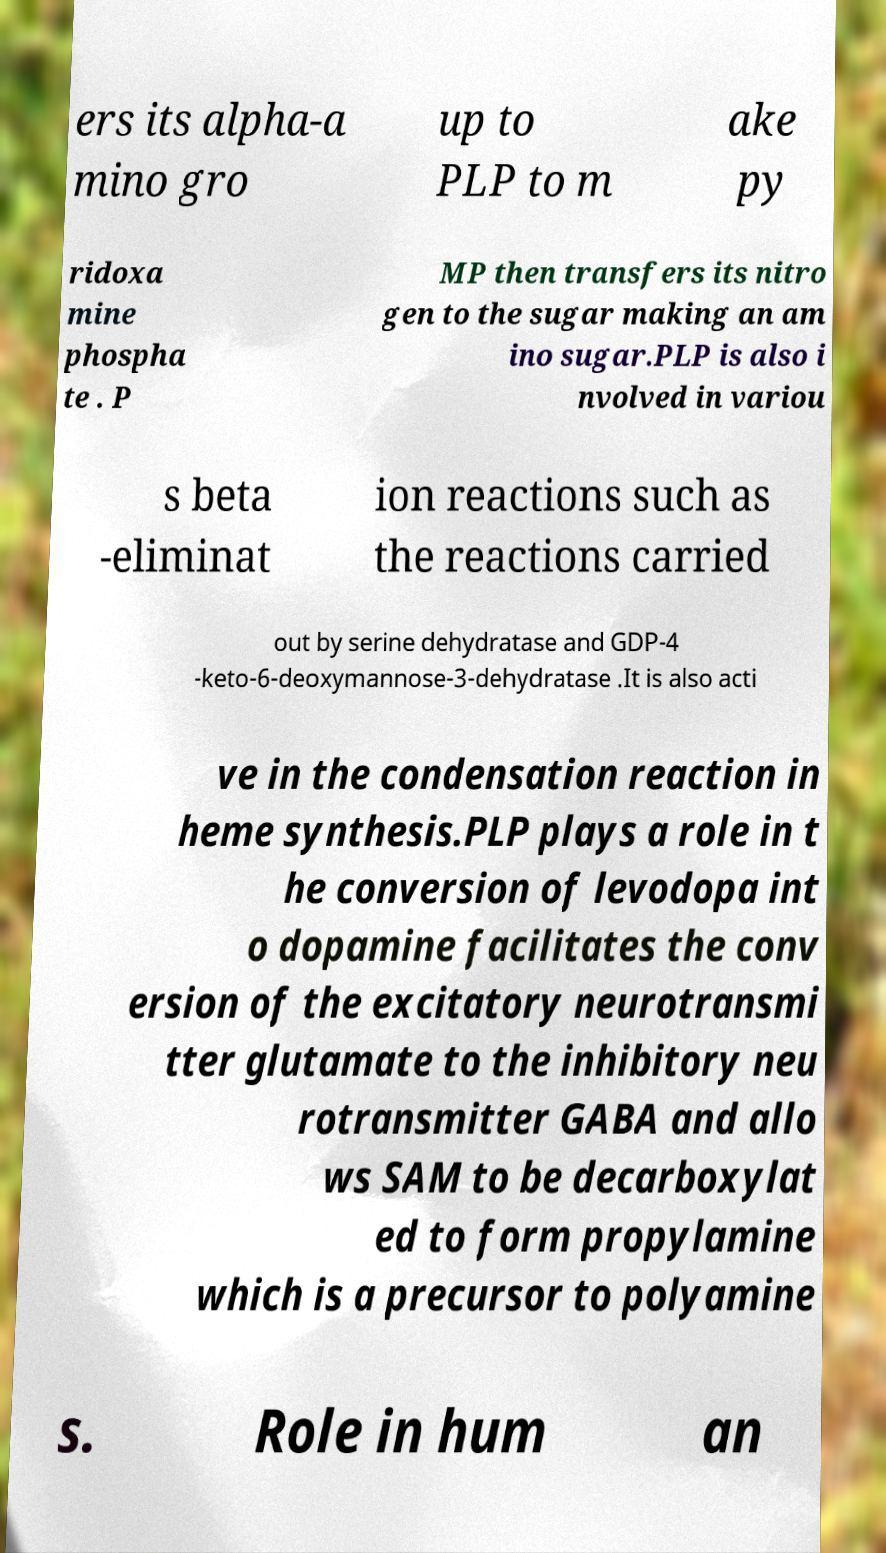For documentation purposes, I need the text within this image transcribed. Could you provide that? ers its alpha-a mino gro up to PLP to m ake py ridoxa mine phospha te . P MP then transfers its nitro gen to the sugar making an am ino sugar.PLP is also i nvolved in variou s beta -eliminat ion reactions such as the reactions carried out by serine dehydratase and GDP-4 -keto-6-deoxymannose-3-dehydratase .It is also acti ve in the condensation reaction in heme synthesis.PLP plays a role in t he conversion of levodopa int o dopamine facilitates the conv ersion of the excitatory neurotransmi tter glutamate to the inhibitory neu rotransmitter GABA and allo ws SAM to be decarboxylat ed to form propylamine which is a precursor to polyamine s. Role in hum an 